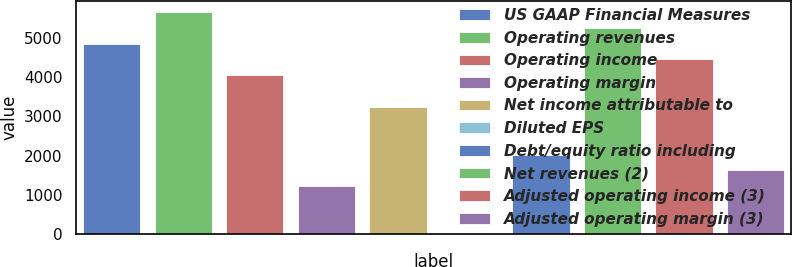Convert chart to OTSL. <chart><loc_0><loc_0><loc_500><loc_500><bar_chart><fcel>US GAAP Financial Measures<fcel>Operating revenues<fcel>Operating income<fcel>Operating margin<fcel>Net income attributable to<fcel>Diluted EPS<fcel>Debt/equity ratio including<fcel>Net revenues (2)<fcel>Adjusted operating income (3)<fcel>Adjusted operating margin (3)<nl><fcel>4860.17<fcel>5669.95<fcel>4050.39<fcel>1216.16<fcel>3240.61<fcel>1.49<fcel>2025.94<fcel>5265.06<fcel>4455.28<fcel>1621.05<nl></chart> 